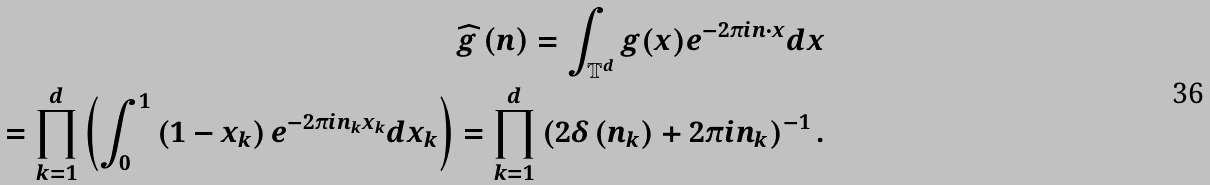<formula> <loc_0><loc_0><loc_500><loc_500>\widehat { g } \left ( n \right ) = \int _ { \mathbb { T } ^ { d } } g ( x ) e ^ { - 2 \pi i n \cdot x } d x \\ = \prod _ { k = 1 } ^ { d } \left ( \int _ { 0 } ^ { 1 } \left ( 1 - x _ { k } \right ) e ^ { - 2 \pi i n _ { k } x _ { k } } d x _ { k } \right ) = \prod _ { k = 1 } ^ { d } \left ( 2 \delta \left ( n _ { k } \right ) + 2 \pi i n _ { k } \right ) ^ { - 1 } .</formula> 